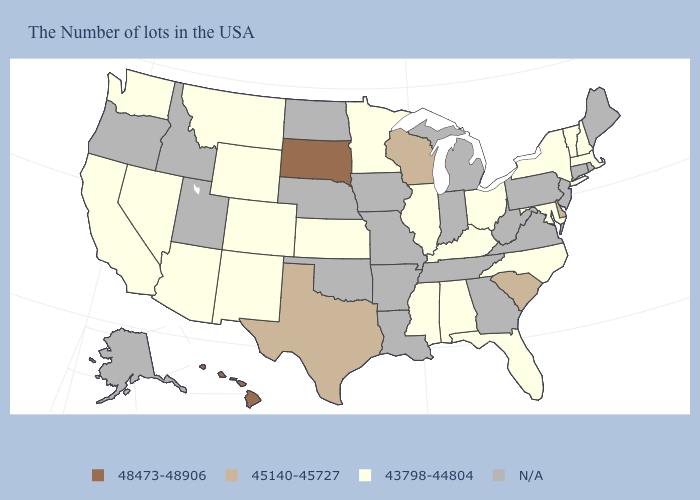Does the first symbol in the legend represent the smallest category?
Short answer required. No. What is the value of Oregon?
Concise answer only. N/A. What is the value of Florida?
Keep it brief. 43798-44804. What is the value of Connecticut?
Keep it brief. N/A. What is the value of Tennessee?
Answer briefly. N/A. Name the states that have a value in the range 48473-48906?
Give a very brief answer. South Dakota, Hawaii. Name the states that have a value in the range 48473-48906?
Short answer required. South Dakota, Hawaii. What is the highest value in the USA?
Write a very short answer. 48473-48906. What is the value of Maryland?
Answer briefly. 43798-44804. Which states hav the highest value in the South?
Answer briefly. Delaware, South Carolina, Texas. Which states hav the highest value in the West?
Write a very short answer. Hawaii. Which states have the highest value in the USA?
Keep it brief. South Dakota, Hawaii. What is the lowest value in states that border Montana?
Be succinct. 43798-44804. Which states have the highest value in the USA?
Concise answer only. South Dakota, Hawaii. 